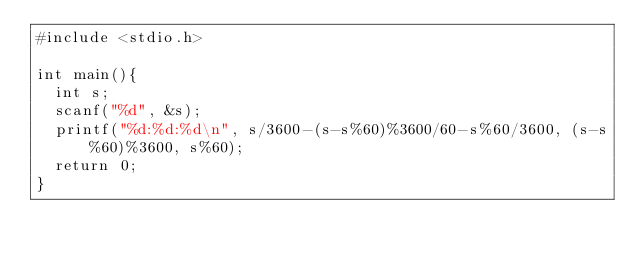<code> <loc_0><loc_0><loc_500><loc_500><_C_>#include <stdio.h>

int main(){
  int s;
  scanf("%d", &s);
  printf("%d:%d:%d\n", s/3600-(s-s%60)%3600/60-s%60/3600, (s-s%60)%3600, s%60);
  return 0;
}</code> 